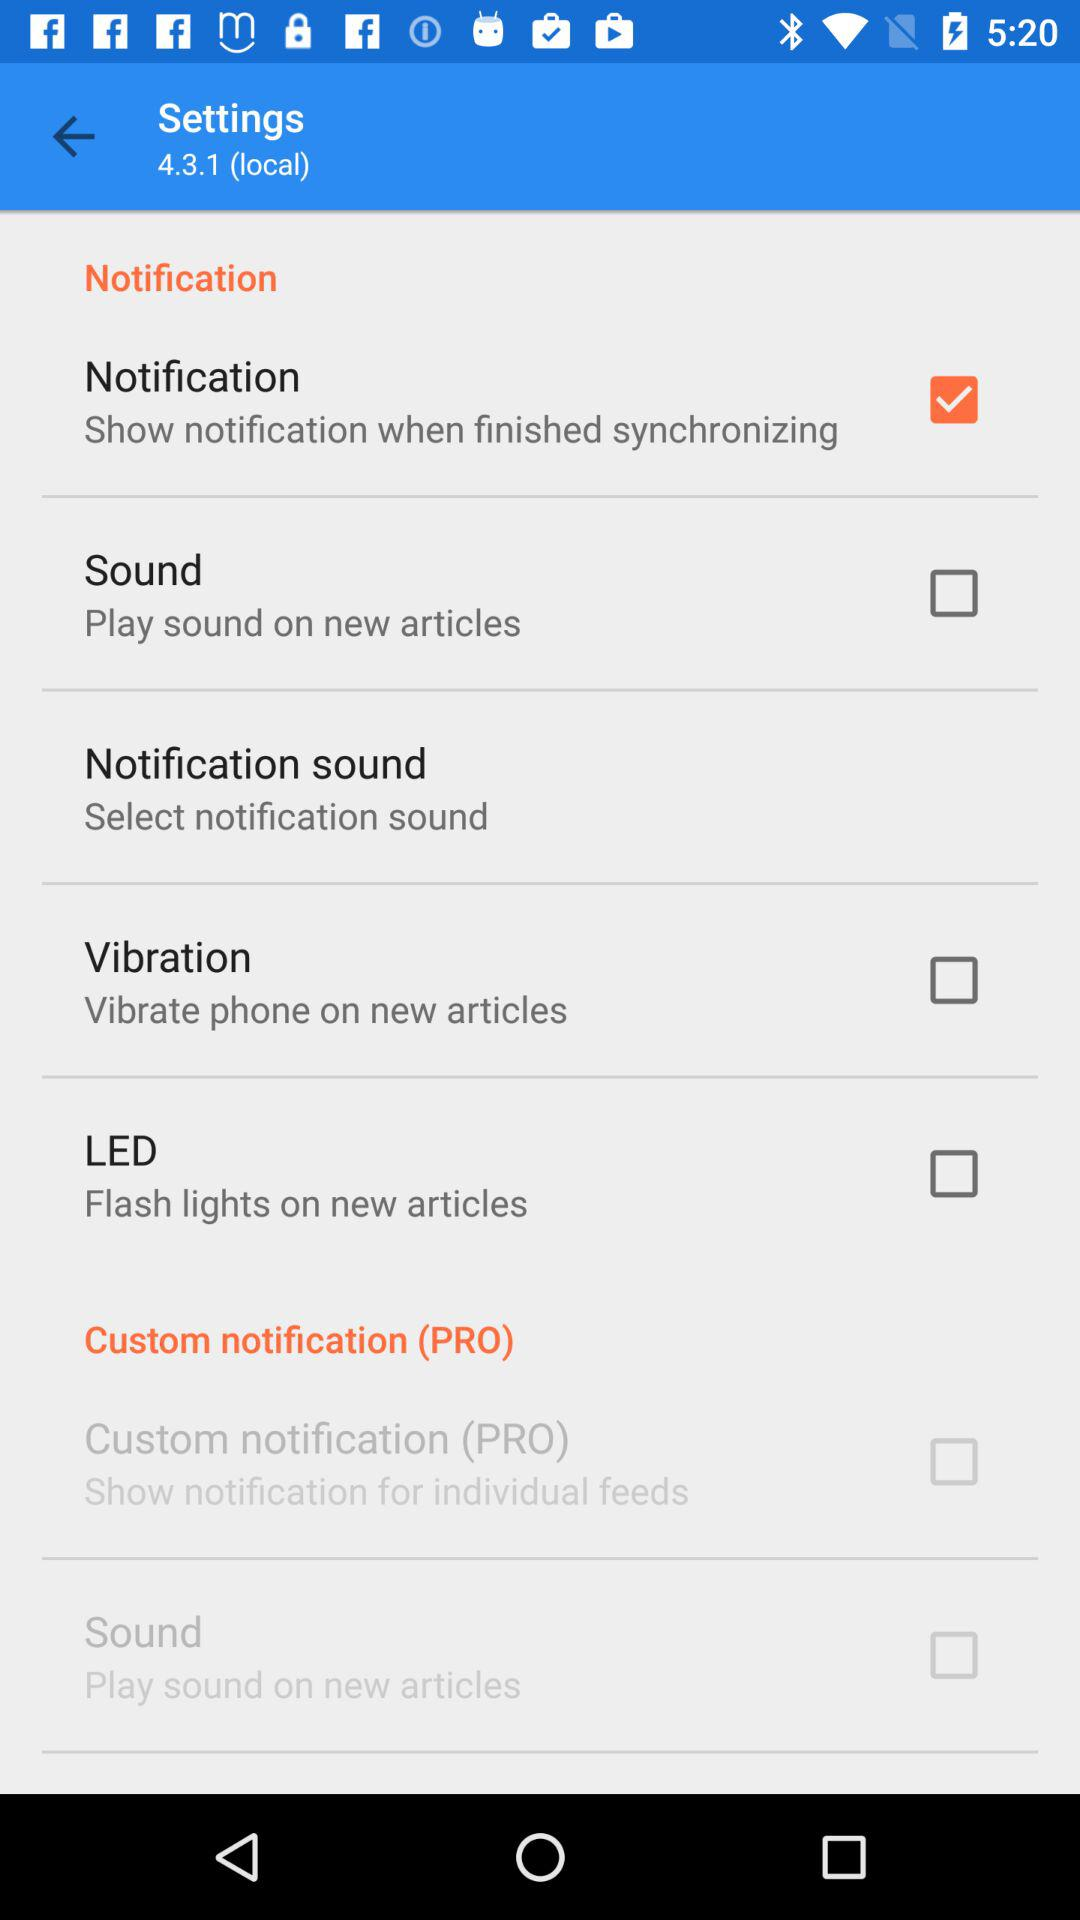What is the status of the notification? The status is on. 